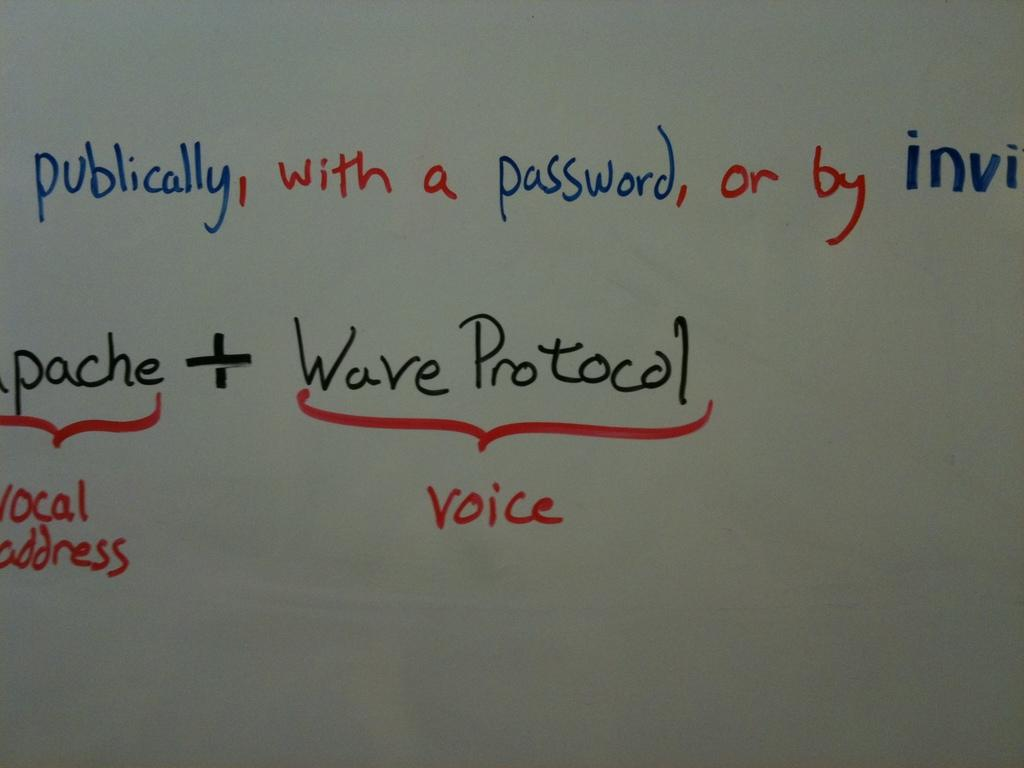Provide a one-sentence caption for the provided image. White board that contains information on waves and voice. 